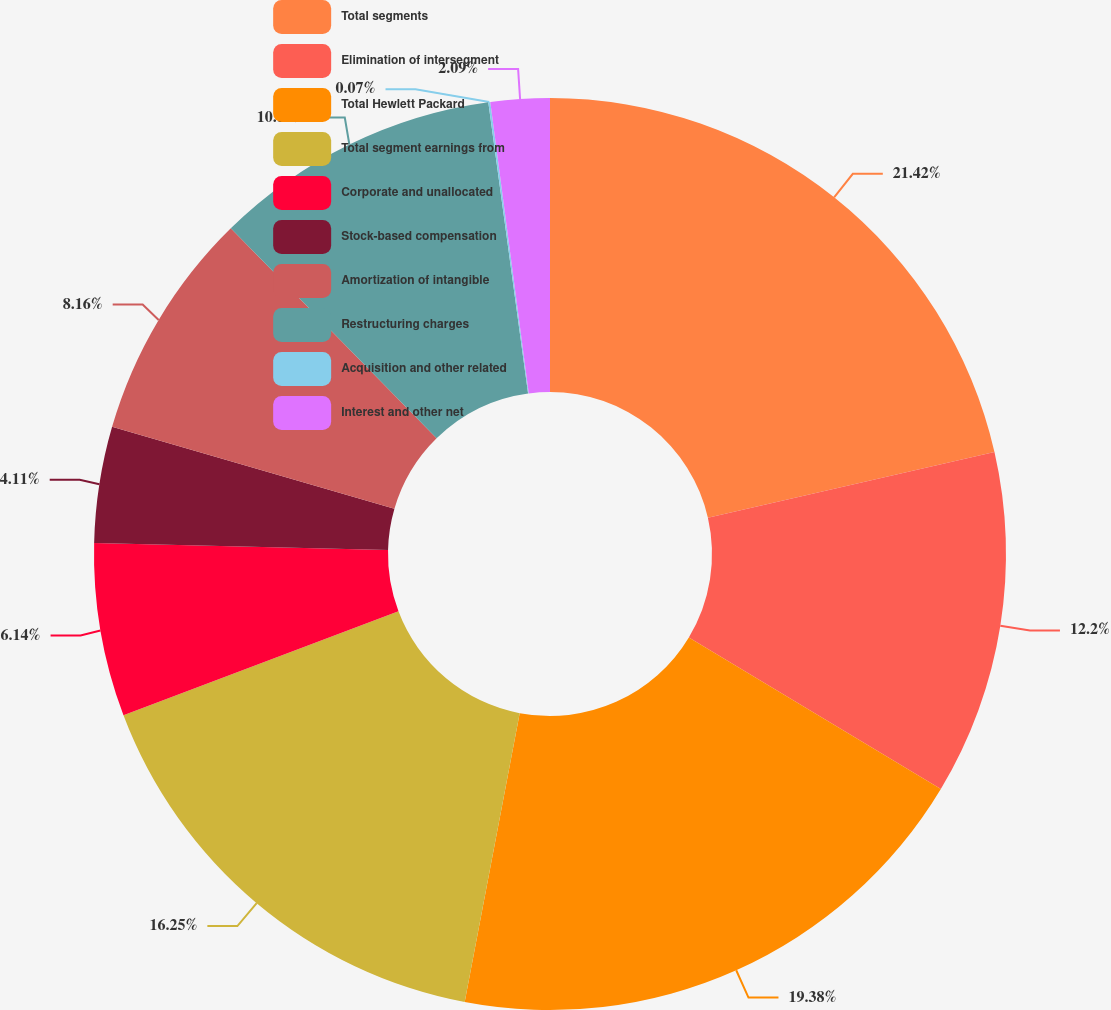<chart> <loc_0><loc_0><loc_500><loc_500><pie_chart><fcel>Total segments<fcel>Elimination of intersegment<fcel>Total Hewlett Packard<fcel>Total segment earnings from<fcel>Corporate and unallocated<fcel>Stock-based compensation<fcel>Amortization of intangible<fcel>Restructuring charges<fcel>Acquisition and other related<fcel>Interest and other net<nl><fcel>21.41%<fcel>12.2%<fcel>19.38%<fcel>16.25%<fcel>6.14%<fcel>4.11%<fcel>8.16%<fcel>10.18%<fcel>0.07%<fcel>2.09%<nl></chart> 